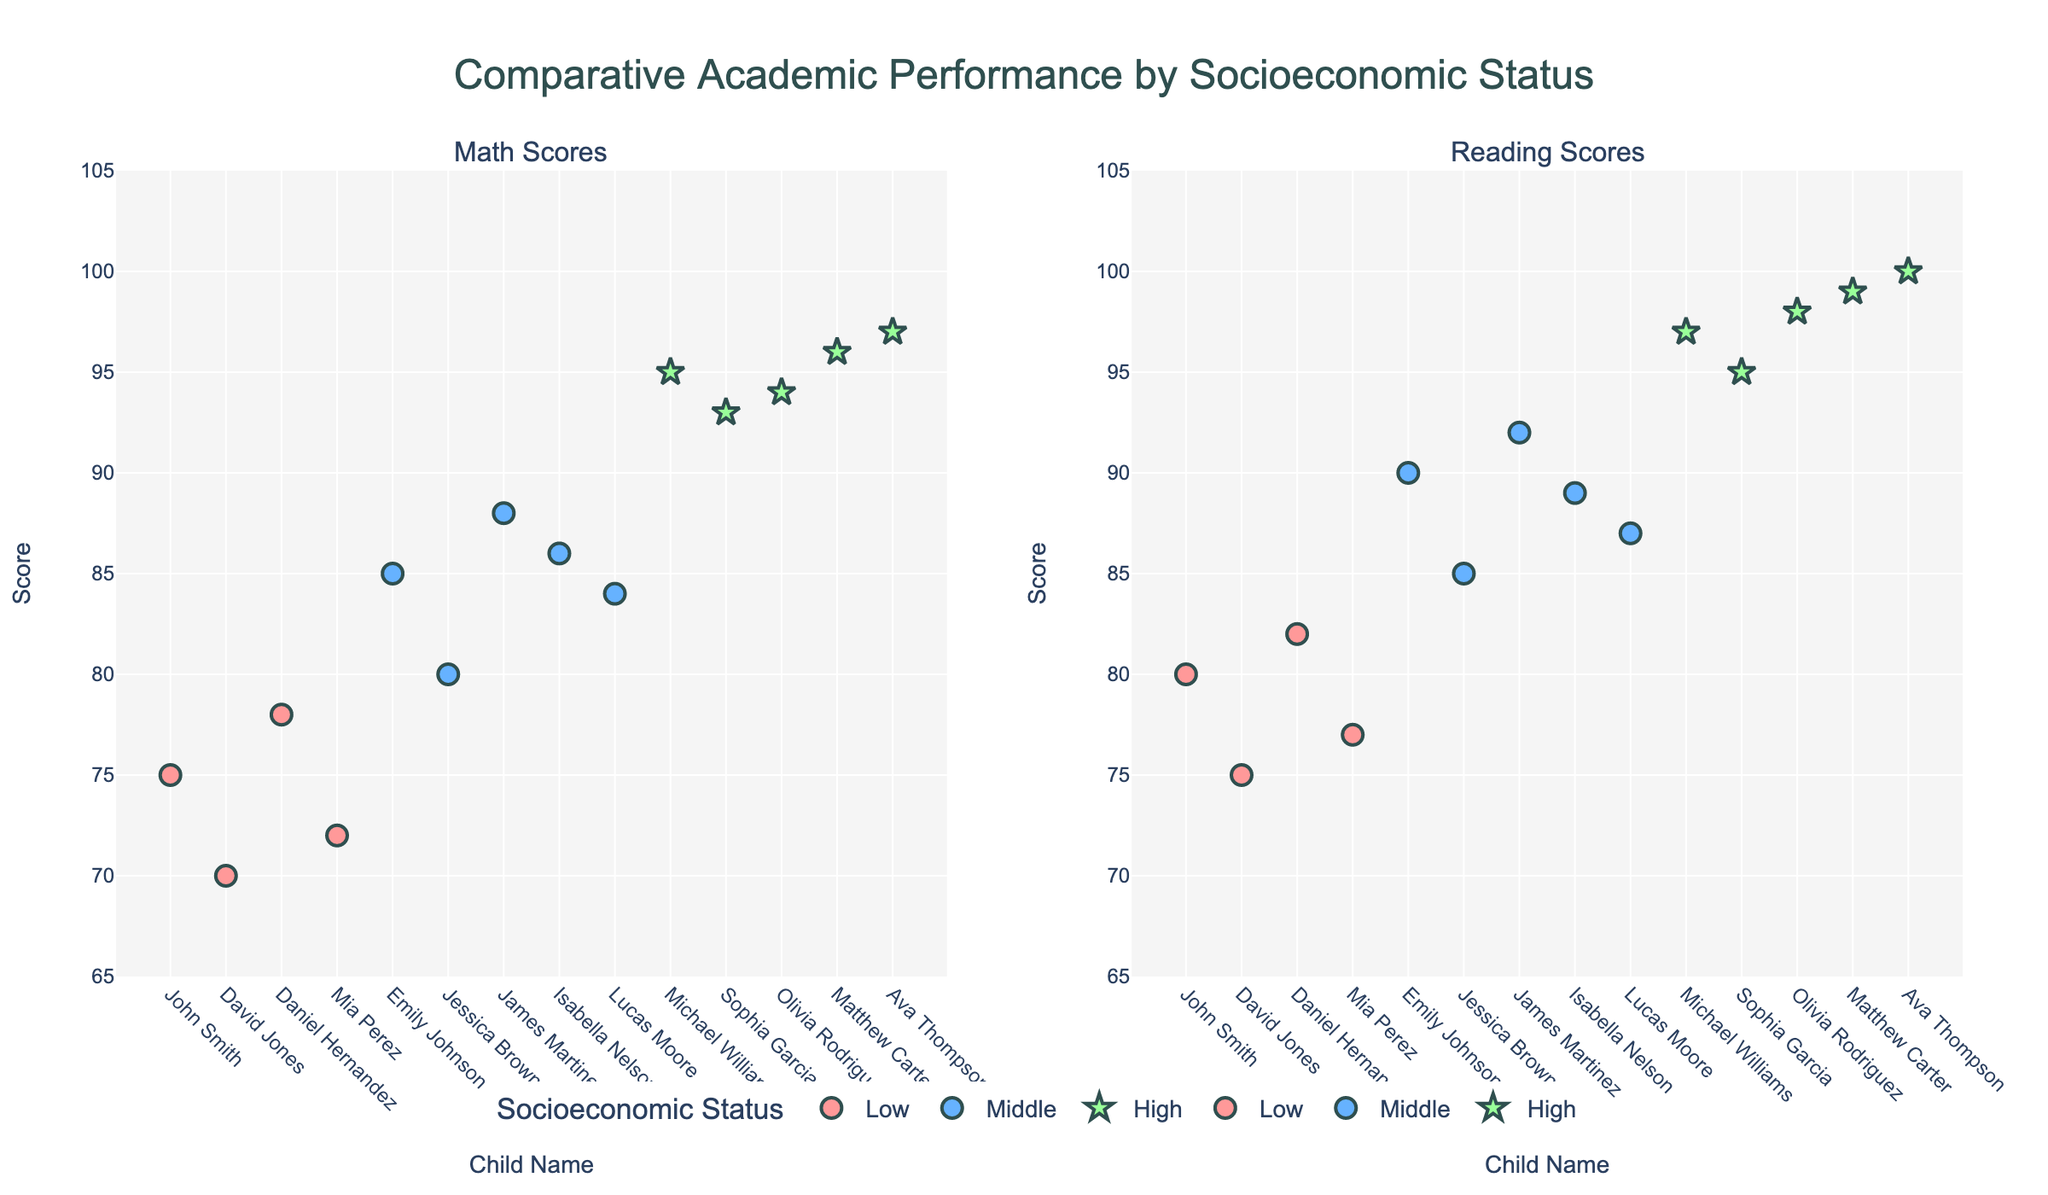Which socioeconomic status group has the highest average math score? To determine this, we look at the average math scores for each socioeconomic status group: Low, Middle, and High. We sum the math scores within each group and then divide by the number of children in each group. Low: (75 + 70 + 78 + 72)/4 = 73.75, Middle: (85 + 80 + 88 + 86 + 84)/5 = 84.6, High: (95 + 93 + 94 + 96 + 97)/5 = 95.
Answer: High Are there more competitive children in the high socioeconomic status group or the middle socioeconomic status group? Observing the figure, we see star markers indicating competitive children. We count the number of stars in each group. High: 5 (Michael, Sophia, Olivia, Matthew, Ava), Middle: 0.
Answer: High What is the range of reading scores for children in the low socioeconomic status group? The range is calculated as the difference between the maximum and minimum reading scores within the group. For Low: The scores are 80, 75, 82, and 77. The range is 82 - 75 = 7.
Answer: 7 Compare the highest reading score among the low, middle, and high socioeconomic status groups. Which group has the highest score? We look at the highest reading scores for each group. Low: 82, Middle: 92, High: 100. Comparing these, the highest is in the High group.
Answer: High Which child has the lowest math score, and what is their socioeconomic status? From the figure, we check all the individual math scores. The lowest score is 70 (David Jones), who is in the low socioeconomic status group.
Answer: David Jones, Low How do the average reading scores of the middle and high socioeconomic status groups compare? Calculate the average reading score for both groups. Middle: (90 + 85 + 92 + 89 + 87)/5 = 88.6, High: (97 + 95 + 98 + 99 + 100)/5 = 97.8. The high group has a higher average.
Answer: High Are any children in the middle socioeconomic status group above the highest math score in the low socioeconomic status group? The highest math score in the Low group is 78. In the Middle group: 85, 80, 88, 86, and 84, all five scores are above 78.
Answer: Yes How many total data points are shown in the figure? Each child represents a data point, and there are 14 children in total.
Answer: 14 